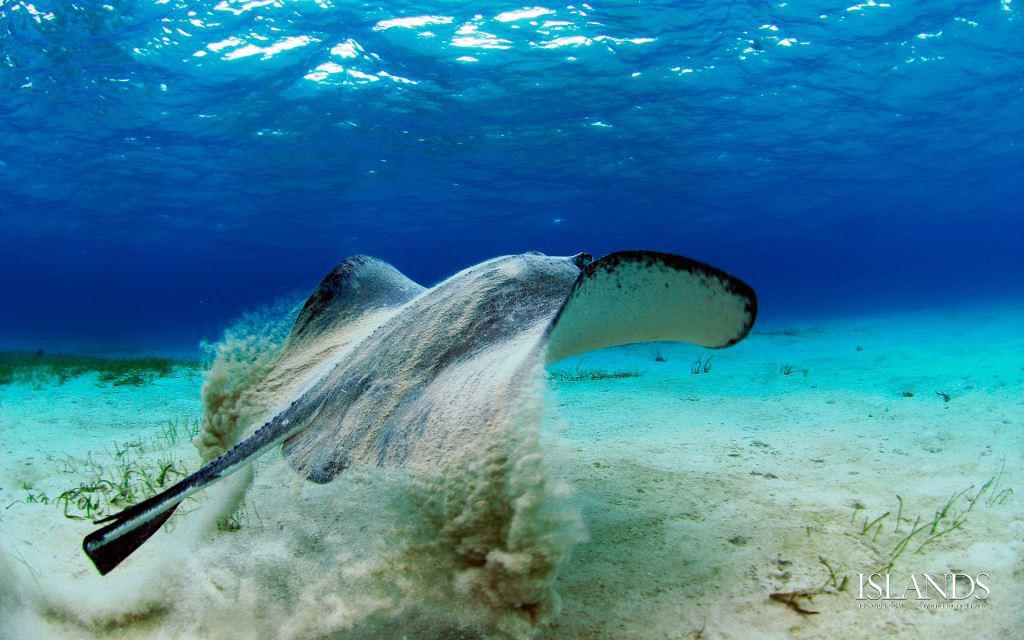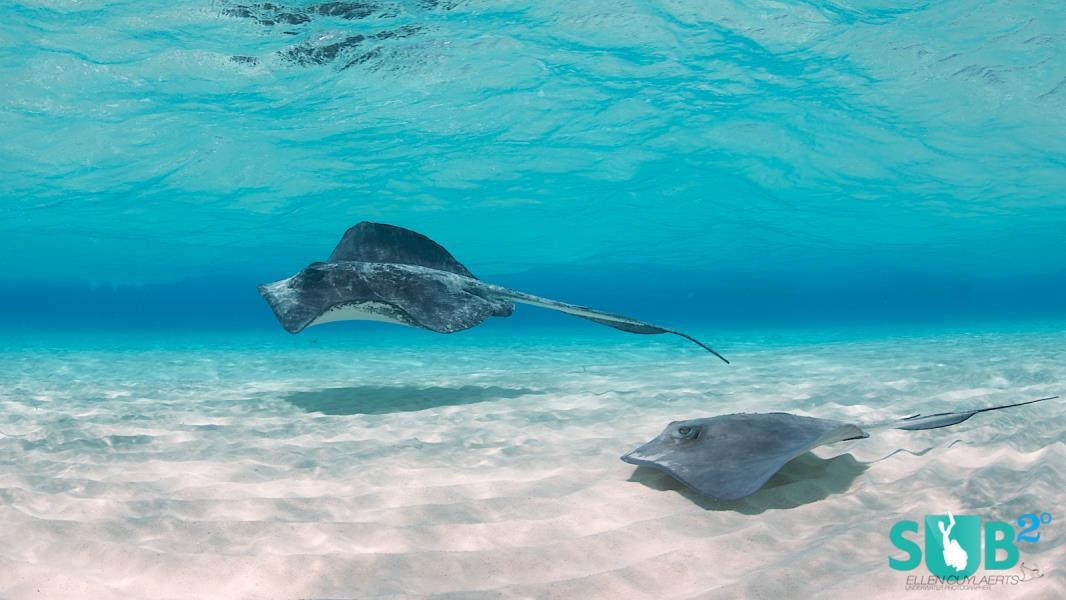The first image is the image on the left, the second image is the image on the right. Examine the images to the left and right. Is the description "a stingray is moving the sandy ocean bottom move while swimming" accurate? Answer yes or no. Yes. The first image is the image on the left, the second image is the image on the right. Assess this claim about the two images: "The right image features two rays.". Correct or not? Answer yes or no. Yes. 